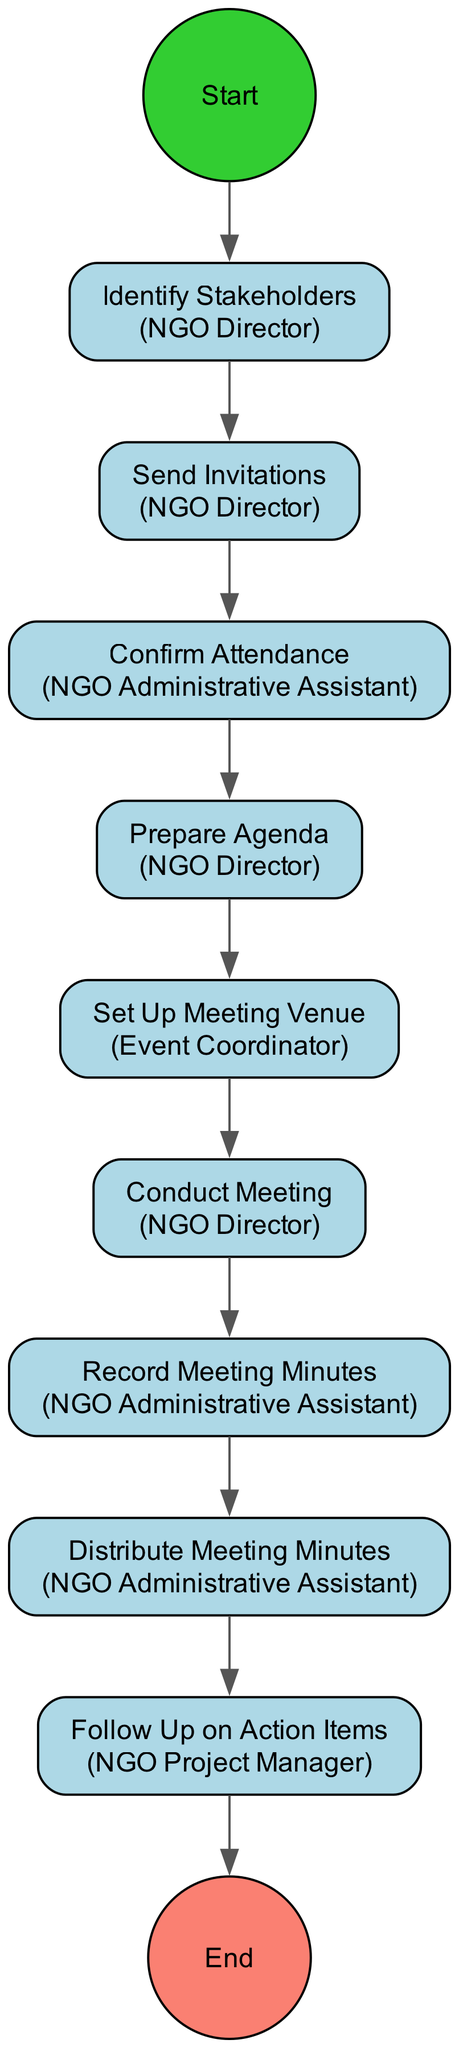What is the first activity in the diagram? The first activity is represented by an arrow coming from the start node, which leads to the "Identify Stakeholders" activity.
Answer: Identify Stakeholders Who is responsible for confirming attendance? The arrow leading to "Confirm Attendance" indicates that the "NGO Administrative Assistant" is the actor responsible for this activity.
Answer: NGO Administrative Assistant How many total activities are in the diagram? By counting the nodes between the start and end nodes, there are a total of nine activities listed in the diagram.
Answer: 9 Which activity is followed directly after "Send Invitations"? The edge leading out from "Send Invitations" connects to the "Confirm Attendance" activity, indicating that it directly follows "Send Invitations".
Answer: Confirm Attendance What does "Conduct Meeting" involve? "Conduct Meeting" is about facilitating discussions, as described in the activity's description. The explanation involves facilitating discussions on environmental project goals, roles, and next steps.
Answer: Facilitate discussions Which actor prepares the agenda for the meeting? The arrow from the "Prepare Agenda" activity indicates that the "NGO Director" is the actor who prepares the agenda for the meeting.
Answer: NGO Director What is the last activity before the meeting minutes are distributed? The sequence of activities shows that "Record Meeting Minutes" occurs immediately before "Distribute Meeting Minutes", confirming it as the last activity before distribution.
Answer: Record Meeting Minutes Who is responsible for following up on action items? The arrow leading to "Follow Up on Action Items" shows that this activity is assigned to the "NGO Project Manager", indicating their responsibility for this task.
Answer: NGO Project Manager What action does the NGO Director take after identifying stakeholders? The arrow leading from "Identify Stakeholders" shows that the next action is "Send Invitations". Therefore, this indicates the NGO Director sends invitations after identifying stakeholders.
Answer: Send Invitations 